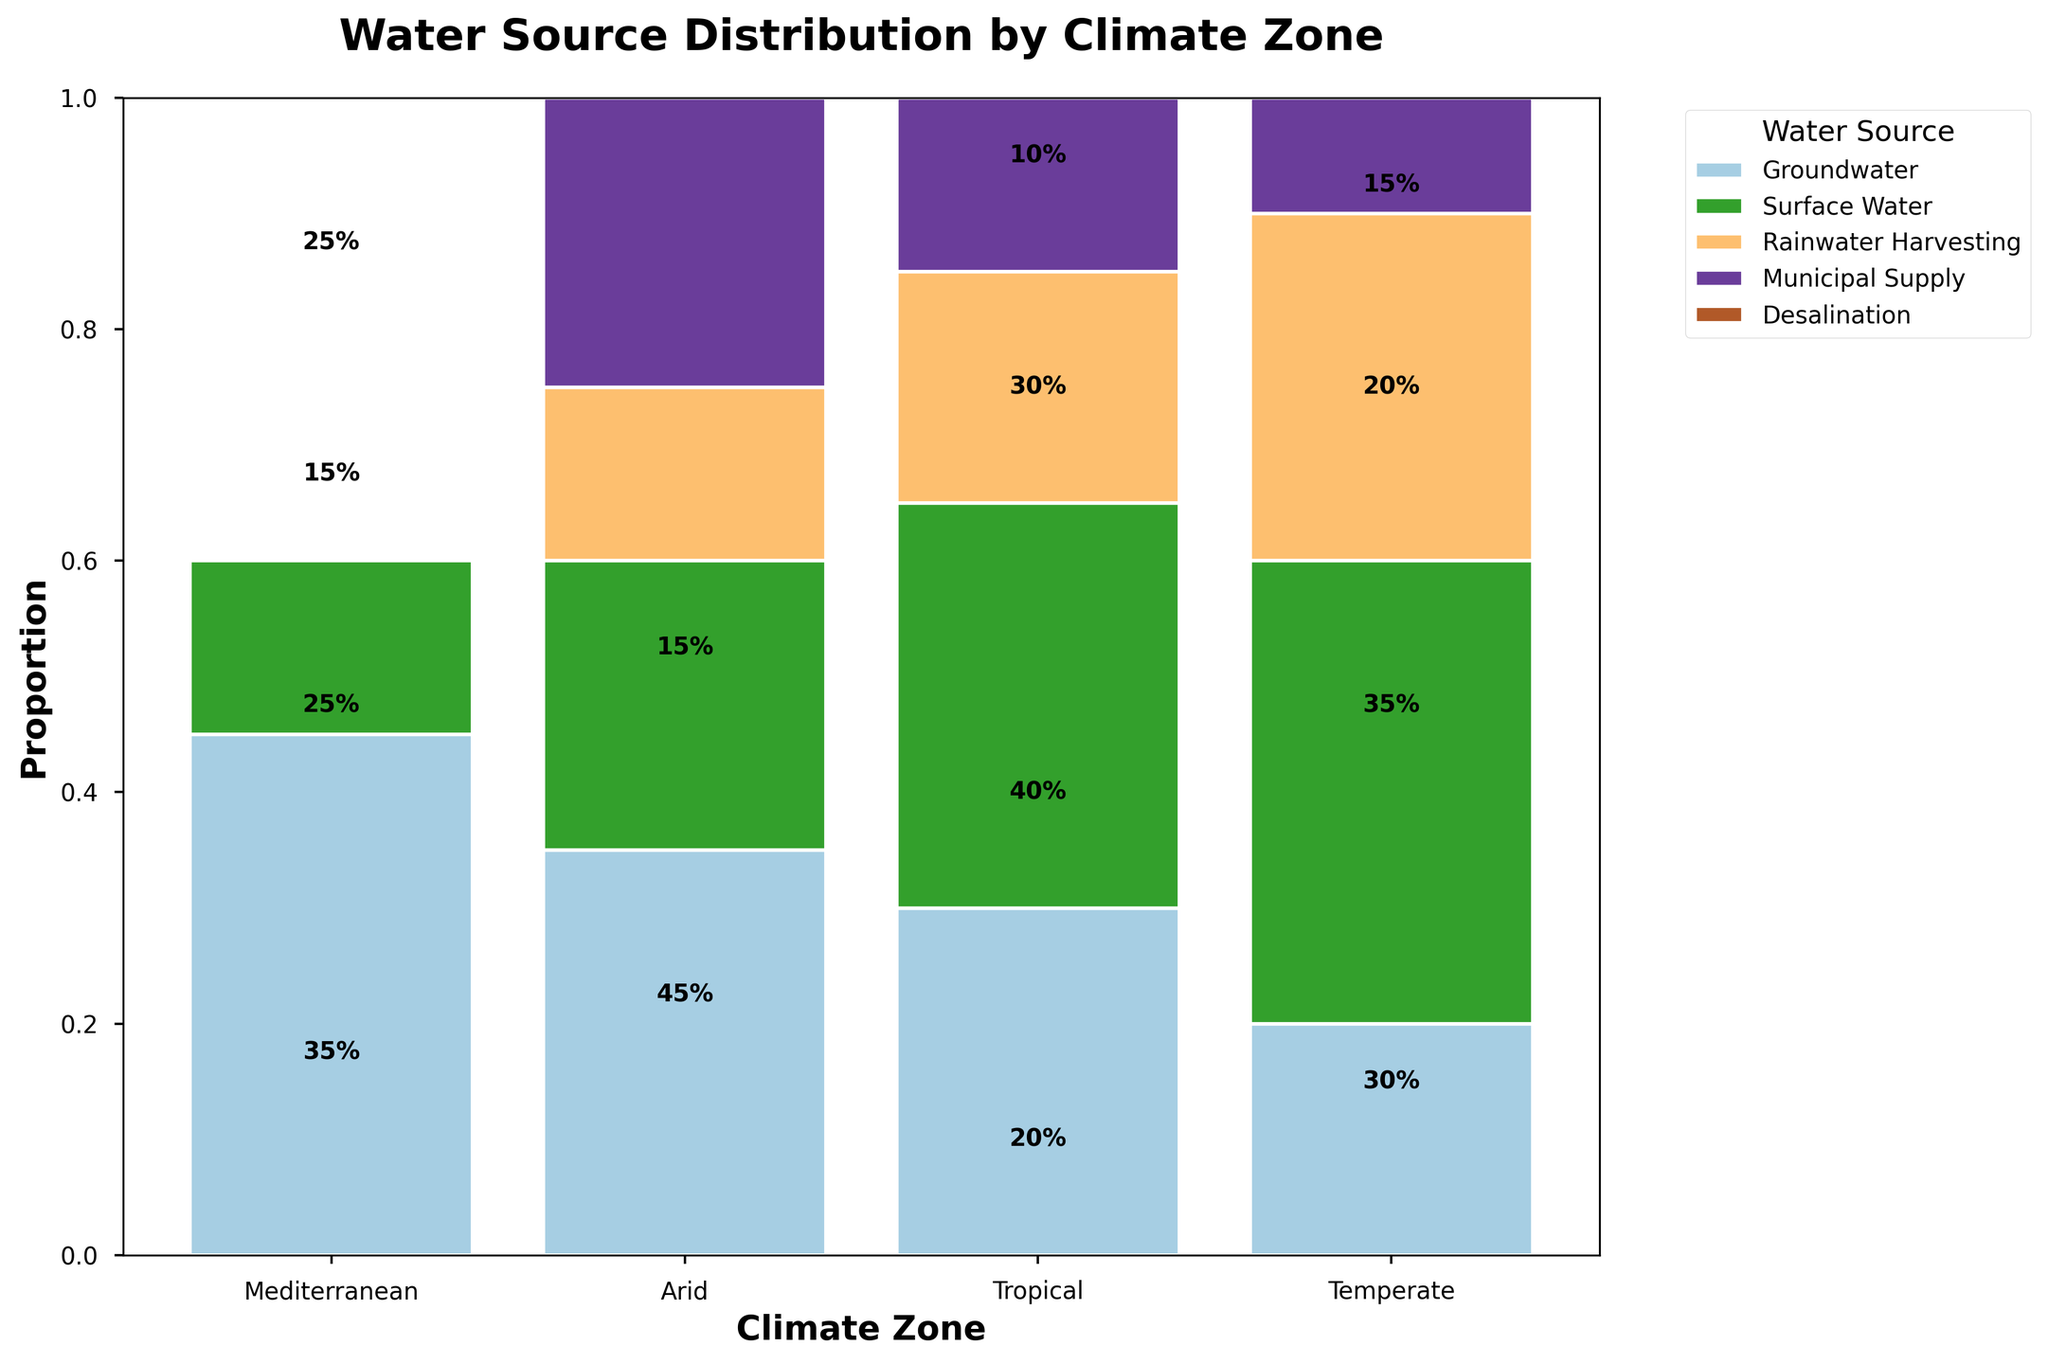What is the most common water source for irrigation in the Arid climate zone? The Arid climate zone has different segments representing water sources such as Groundwater, Surface Water, Desalination, and Municipal Supply. The height of each segment within the Arid category indicates its proportion. The Groundwater segment is the tallest, indicating it is the most common.
Answer: Groundwater How many climate zones show Rainwater Harvesting as a water source for irrigation? Look for the segments of Rainwater Harvesting color in the plot. Identify the number of climate zones where this color appears. Rainwater Harvesting appears in the Mediterranean, Tropical, and Temperate climate zones.
Answer: 3 Which climate zone has the highest proportion of Surface Water as a water source? Compare the heights of the segments labeled "Surface Water" across all climate zones. The Tropical zone shows the highest segment for Surface Water.
Answer: Tropical What is the total proportion of Groundwater in the Mediterranean and Temperate climate zones combined? Identify and sum the proportions of the Groundwater segments in both the Mediterranean and Temperate climate zones. Groundwater in the Mediterranean is 35% and in the Temperate zone is 30%, which totals 35% + 30% = 65%.
Answer: 65% In which climate zone is Municipal Supply the least utilized as a water source? Examine the Municipal Supply segments in each climate zone and identify the smallest segment. The Arid climate zone has the smallest Municipal Supply segment.
Answer: Arid Compare the proportion of Rainwater Harvesting between the Mediterranean and Tropical climate zones. Which is higher? Look at the segments for Rainwater Harvesting in both the Mediterranean and Tropical zones. The Tropical zone has a higher Rainwater Harvesting proportion compared to the Mediterranean.
Answer: Tropical How does the proportion of Desalination in the Arid climate zone compare to any use of Desalination in other zones? Analyze the segments of Desalination across all climate zones. Desalination is only present in the Arid climate zone, and none in the others, thus Desalination is exclusive to the Arid zone.
Answer: Exclusive to Arid What is the combined proportion of Municipal Supply and Groundwater in the Temperate climate zone? Sum the proportions of the Municipal Supply and Groundwater segments in the Temperate climate zone. Groundwater is 30% and Municipal Supply is 15%. The combined proportion is 30% + 15% = 45%.
Answer: 45% Which water source has the most consistent usage across all climate zones? Evaluate the segments for each water source across all climate zones and determine which one shows relatively even heights. Groundwater appears to have a relatively consistent presence across the climate zones.
Answer: Groundwater 